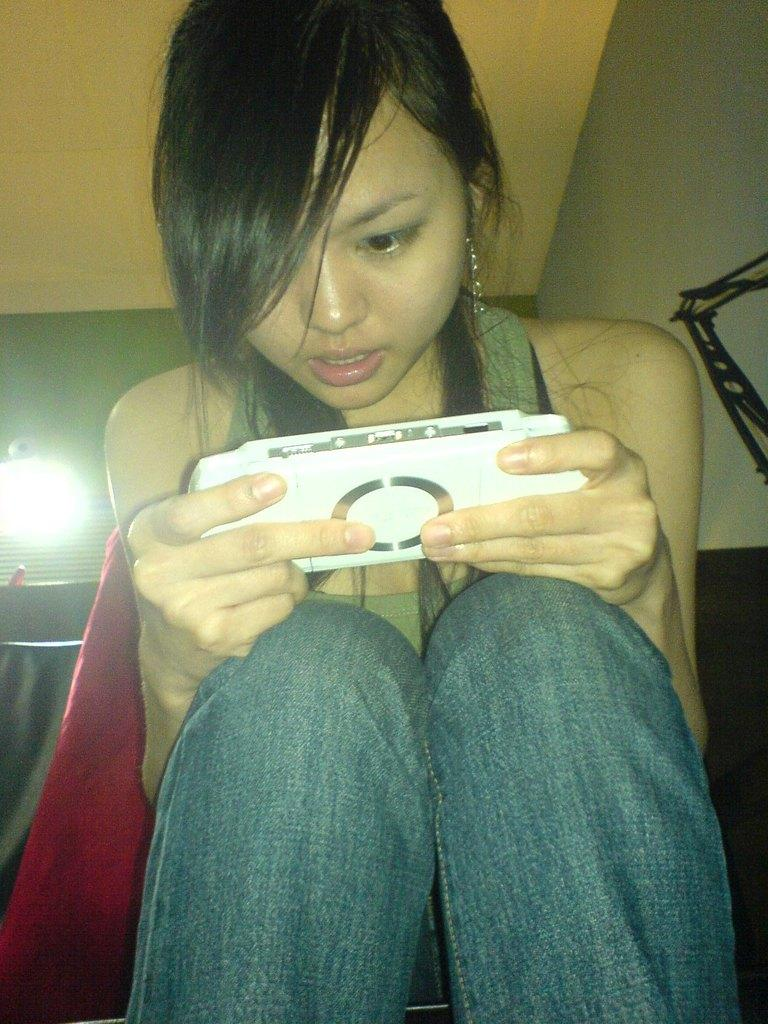Who is present in the image? There is a woman in the image. What is the woman doing with her hands? The woman is holding a device with her hands. What is the woman's posture in the image? The woman is sitting. What can be seen in the background of the image? There is a wall and a light in the background of the image. What type of brush can be seen in the woman's hand in the image? There is no brush present in the woman's hand or in the image. 